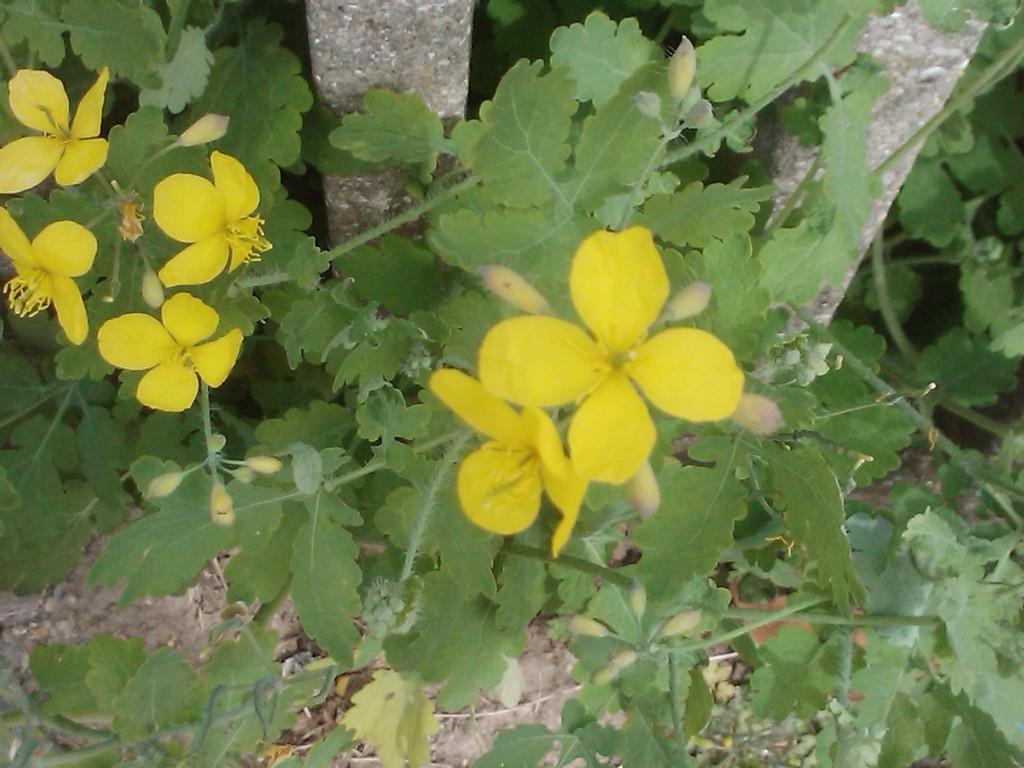Could you give a brief overview of what you see in this image? In this picture we can see flowers, here we can see plants on the ground and in the background tree trunks. 